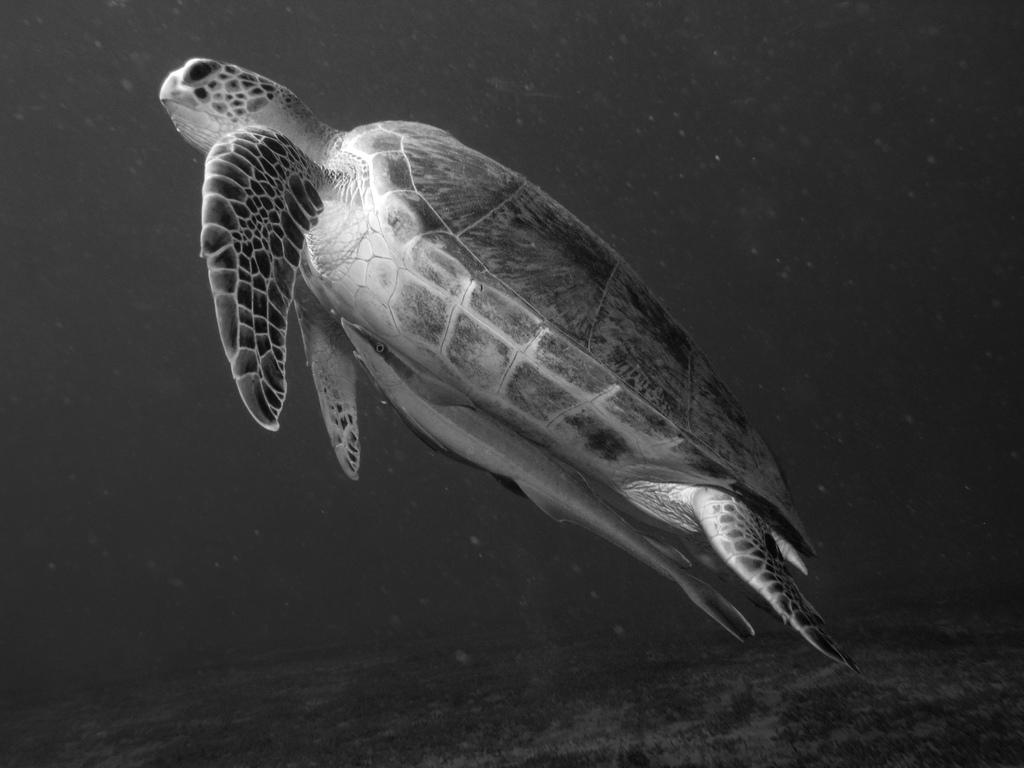What animal is present in the image? There is a turtle in the image. Where is the turtle located? The turtle is in the water. Can you make any assumptions about the environment based on the image? The image may have been taken in the ocean. Is there any information about the time of day when the image was taken? The image may have been taken during the night. What type of loaf can be seen in the image? There is no loaf present in the image. Can you describe the baby playing with the turtle in the image? There is no baby present in the image; it only features a turtle in the water. 